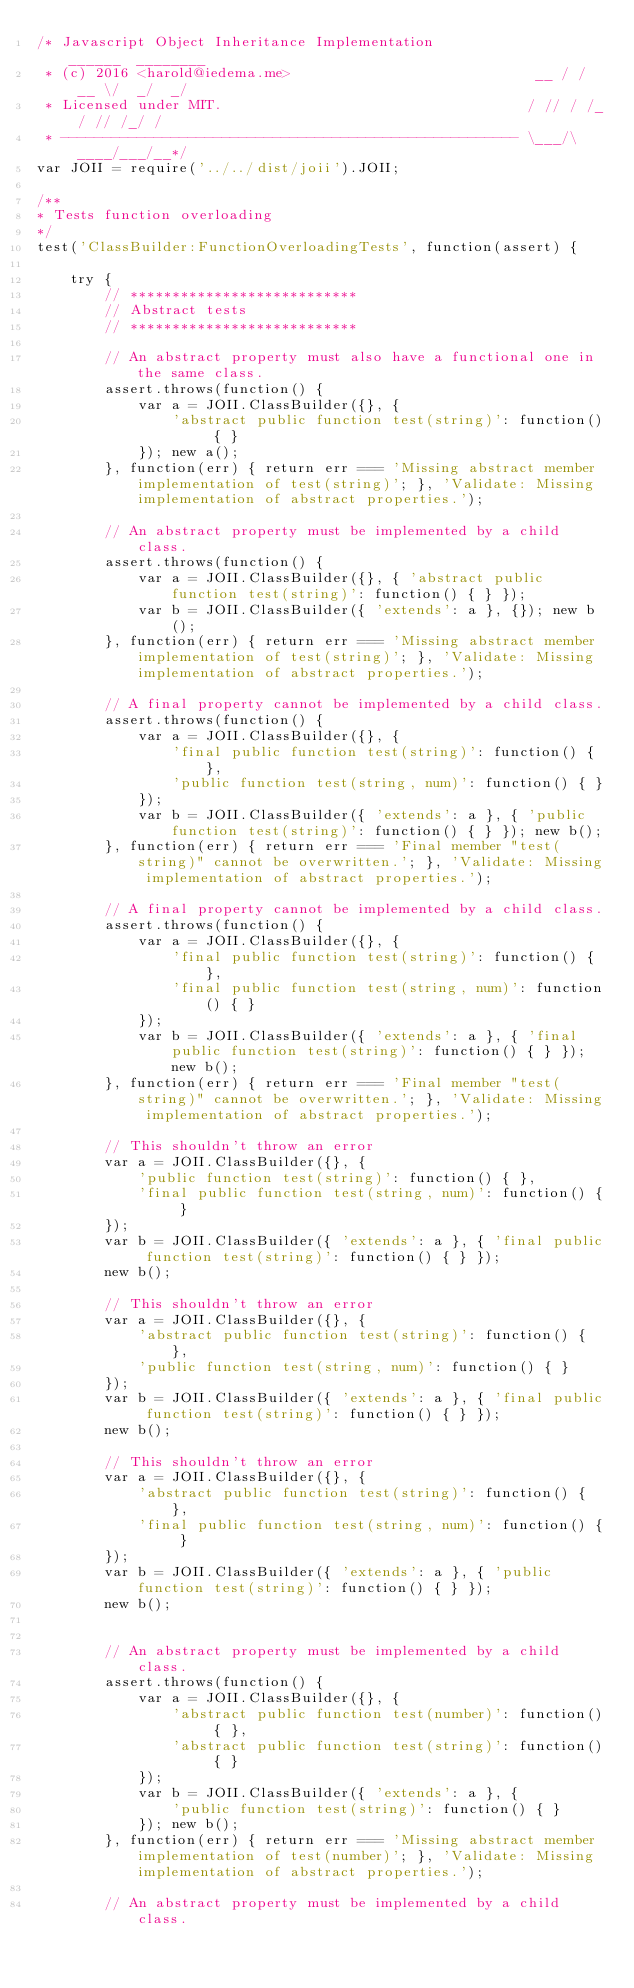<code> <loc_0><loc_0><loc_500><loc_500><_JavaScript_>/* Javascript Object Inheritance Implementation                ______  ________
 * (c) 2016 <harold@iedema.me>                             __ / / __ \/  _/  _/
 * Licensed under MIT.                                    / // / /_/ // /_/ /
 * ------------------------------------------------------ \___/\____/___/__*/
var JOII = require('../../dist/joii').JOII;

/**
* Tests function overloading
*/
test('ClassBuilder:FunctionOverloadingTests', function(assert) {

    try {
        // ***************************
        // Abstract tests
        // ***************************

        // An abstract property must also have a functional one in the same class.
        assert.throws(function() {
            var a = JOII.ClassBuilder({}, {
                'abstract public function test(string)': function() { }
            }); new a();
        }, function(err) { return err === 'Missing abstract member implementation of test(string)'; }, 'Validate: Missing implementation of abstract properties.');

        // An abstract property must be implemented by a child class.
        assert.throws(function() {
            var a = JOII.ClassBuilder({}, { 'abstract public function test(string)': function() { } });
            var b = JOII.ClassBuilder({ 'extends': a }, {}); new b();
        }, function(err) { return err === 'Missing abstract member implementation of test(string)'; }, 'Validate: Missing implementation of abstract properties.');

        // A final property cannot be implemented by a child class.
        assert.throws(function() {
            var a = JOII.ClassBuilder({}, {
                'final public function test(string)': function() { },
                'public function test(string, num)': function() { }
            });
            var b = JOII.ClassBuilder({ 'extends': a }, { 'public function test(string)': function() { } }); new b();
        }, function(err) { return err === 'Final member "test(string)" cannot be overwritten.'; }, 'Validate: Missing implementation of abstract properties.');

        // A final property cannot be implemented by a child class.
        assert.throws(function() {
            var a = JOII.ClassBuilder({}, {
                'final public function test(string)': function() { },
                'final public function test(string, num)': function() { }
            });
            var b = JOII.ClassBuilder({ 'extends': a }, { 'final public function test(string)': function() { } }); new b();
        }, function(err) { return err === 'Final member "test(string)" cannot be overwritten.'; }, 'Validate: Missing implementation of abstract properties.');

        // This shouldn't throw an error
        var a = JOII.ClassBuilder({}, {
            'public function test(string)': function() { },
            'final public function test(string, num)': function() { }
        });
        var b = JOII.ClassBuilder({ 'extends': a }, { 'final public function test(string)': function() { } });
        new b();

        // This shouldn't throw an error
        var a = JOII.ClassBuilder({}, {
            'abstract public function test(string)': function() { },
            'public function test(string, num)': function() { }
        });
        var b = JOII.ClassBuilder({ 'extends': a }, { 'final public function test(string)': function() { } });
        new b();

        // This shouldn't throw an error
        var a = JOII.ClassBuilder({}, {
            'abstract public function test(string)': function() { },
            'final public function test(string, num)': function() { }
        });
        var b = JOII.ClassBuilder({ 'extends': a }, { 'public function test(string)': function() { } });
        new b();


        // An abstract property must be implemented by a child class.
        assert.throws(function() {
            var a = JOII.ClassBuilder({}, {
                'abstract public function test(number)': function() { },
                'abstract public function test(string)': function() { }
            });
            var b = JOII.ClassBuilder({ 'extends': a }, {
                'public function test(string)': function() { }
            }); new b();
        }, function(err) { return err === 'Missing abstract member implementation of test(number)'; }, 'Validate: Missing implementation of abstract properties.');

        // An abstract property must be implemented by a child class.</code> 